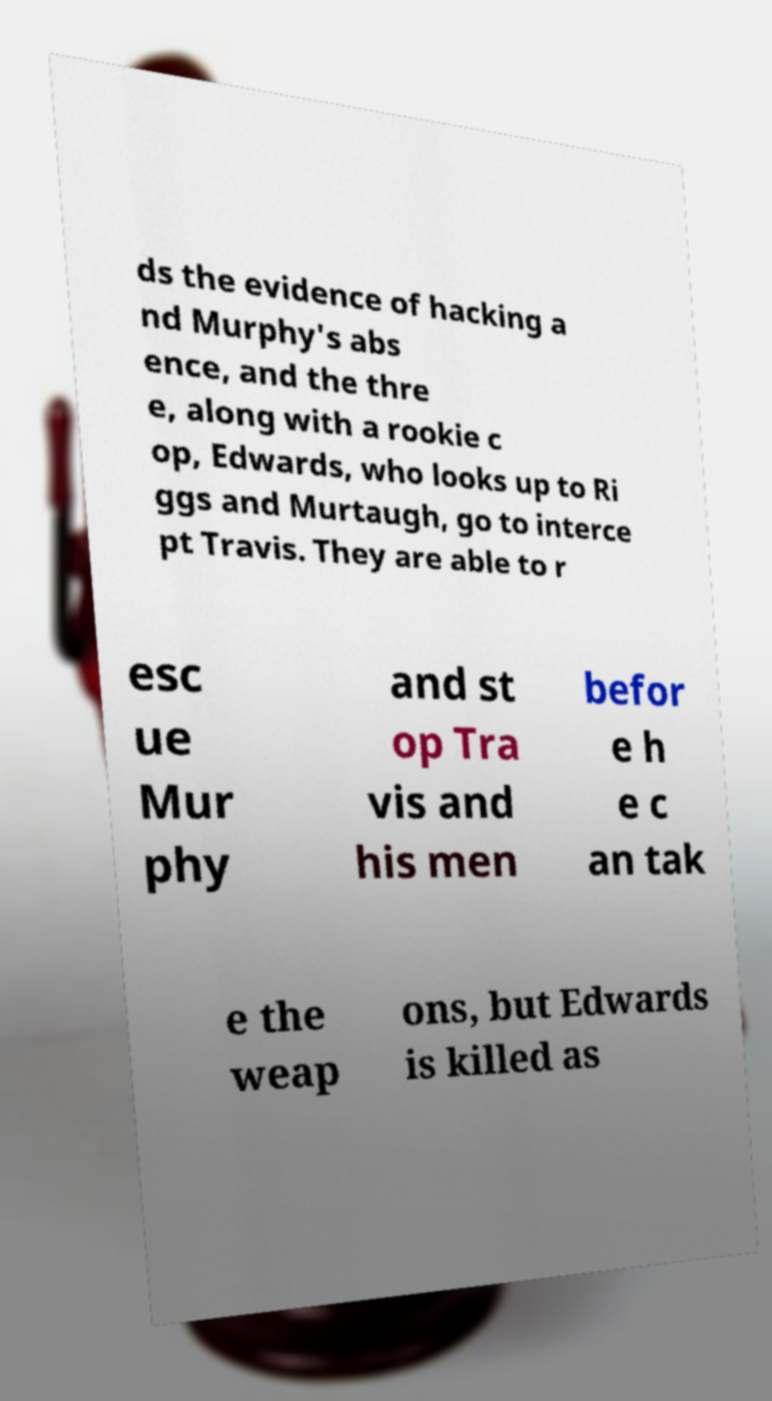Please identify and transcribe the text found in this image. ds the evidence of hacking a nd Murphy's abs ence, and the thre e, along with a rookie c op, Edwards, who looks up to Ri ggs and Murtaugh, go to interce pt Travis. They are able to r esc ue Mur phy and st op Tra vis and his men befor e h e c an tak e the weap ons, but Edwards is killed as 